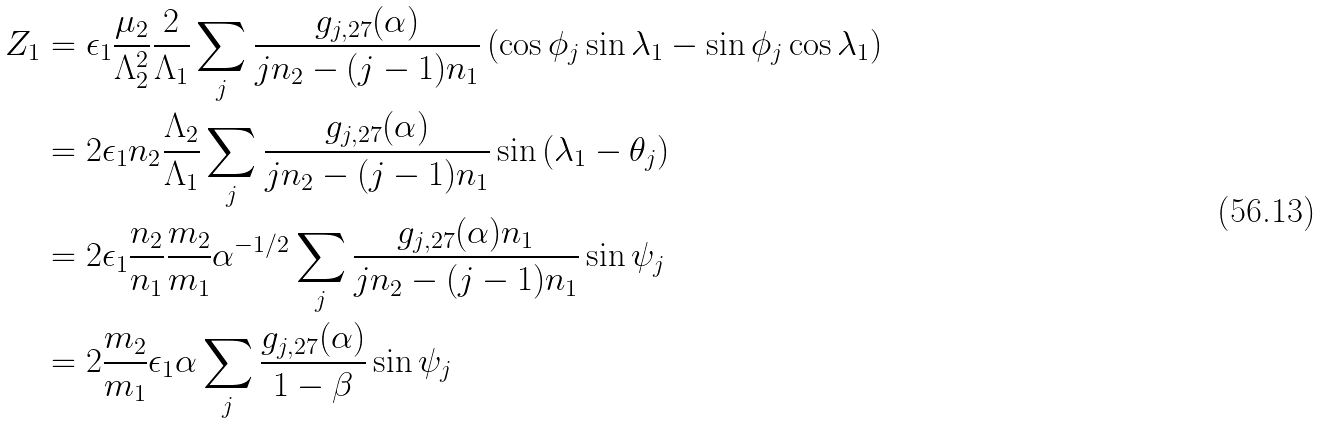Convert formula to latex. <formula><loc_0><loc_0><loc_500><loc_500>Z _ { 1 } & = \epsilon _ { 1 } \frac { \mu _ { 2 } } { { \Lambda } _ { 2 } ^ { 2 } } \frac { 2 } { \Lambda _ { 1 } } \sum _ { j } \frac { g _ { j , 2 7 } ( \alpha ) } { j n _ { 2 } - ( j - 1 ) n _ { 1 } } \left ( \cos { \phi _ { j } } \sin { \lambda _ { 1 } } - \sin { \phi _ { j } } \cos { \lambda _ { 1 } } \right ) \\ & = 2 \epsilon _ { 1 } n _ { 2 } \frac { \Lambda _ { 2 } } { \Lambda _ { 1 } } \sum _ { j } \frac { g _ { j , 2 7 } ( \alpha ) } { j n _ { 2 } - ( j - 1 ) n _ { 1 } } \sin { ( \lambda _ { 1 } - \theta _ { j } ) } \\ & = 2 \epsilon _ { 1 } \frac { n _ { 2 } } { n _ { 1 } } \frac { m _ { 2 } } { m _ { 1 } } \alpha ^ { - 1 / 2 } \sum _ { j } \frac { g _ { j , 2 7 } ( \alpha ) n _ { 1 } } { j n _ { 2 } - ( j - 1 ) n _ { 1 } } \sin { \psi _ { j } } \\ & = 2 \frac { m _ { 2 } } { m _ { 1 } } \epsilon _ { 1 } \alpha \sum _ { j } \frac { g _ { j , 2 7 } ( \alpha ) } { 1 - \beta } \sin { \psi _ { j } }</formula> 